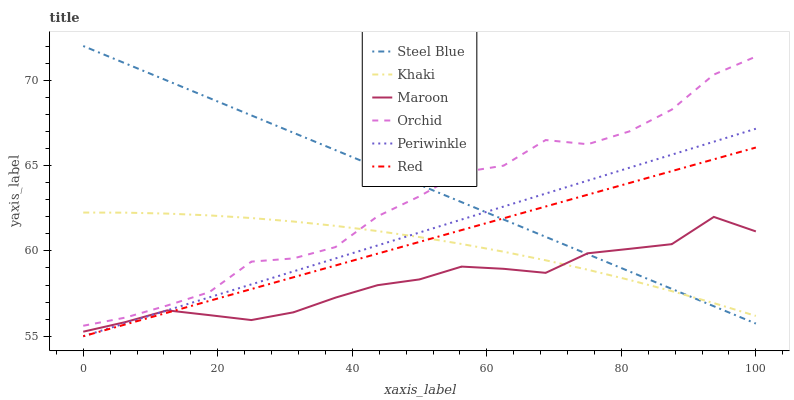Does Maroon have the minimum area under the curve?
Answer yes or no. Yes. Does Steel Blue have the maximum area under the curve?
Answer yes or no. Yes. Does Steel Blue have the minimum area under the curve?
Answer yes or no. No. Does Maroon have the maximum area under the curve?
Answer yes or no. No. Is Red the smoothest?
Answer yes or no. Yes. Is Orchid the roughest?
Answer yes or no. Yes. Is Steel Blue the smoothest?
Answer yes or no. No. Is Steel Blue the roughest?
Answer yes or no. No. Does Periwinkle have the lowest value?
Answer yes or no. Yes. Does Steel Blue have the lowest value?
Answer yes or no. No. Does Steel Blue have the highest value?
Answer yes or no. Yes. Does Maroon have the highest value?
Answer yes or no. No. Is Red less than Orchid?
Answer yes or no. Yes. Is Orchid greater than Maroon?
Answer yes or no. Yes. Does Khaki intersect Maroon?
Answer yes or no. Yes. Is Khaki less than Maroon?
Answer yes or no. No. Is Khaki greater than Maroon?
Answer yes or no. No. Does Red intersect Orchid?
Answer yes or no. No. 